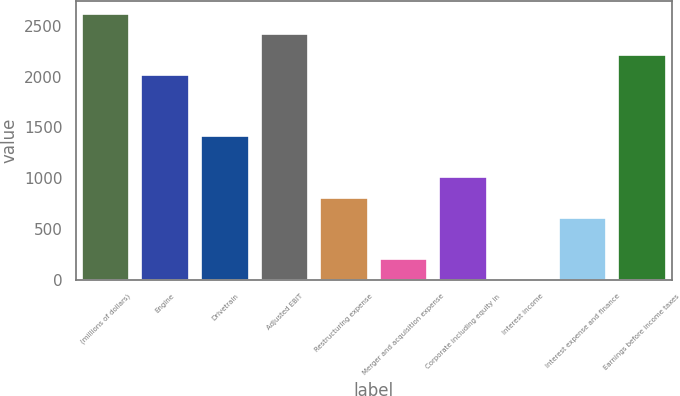<chart> <loc_0><loc_0><loc_500><loc_500><bar_chart><fcel>(millions of dollars)<fcel>Engine<fcel>Drivetrain<fcel>Adjusted EBIT<fcel>Restructuring expense<fcel>Merger and acquisition expense<fcel>Corporate including equity in<fcel>Interest income<fcel>Interest expense and finance<fcel>Earnings before income taxes<nl><fcel>2617.25<fcel>2015<fcel>1412.75<fcel>2416.5<fcel>810.5<fcel>208.25<fcel>1011.25<fcel>7.5<fcel>609.75<fcel>2215.75<nl></chart> 